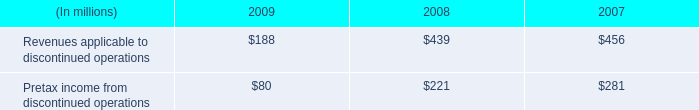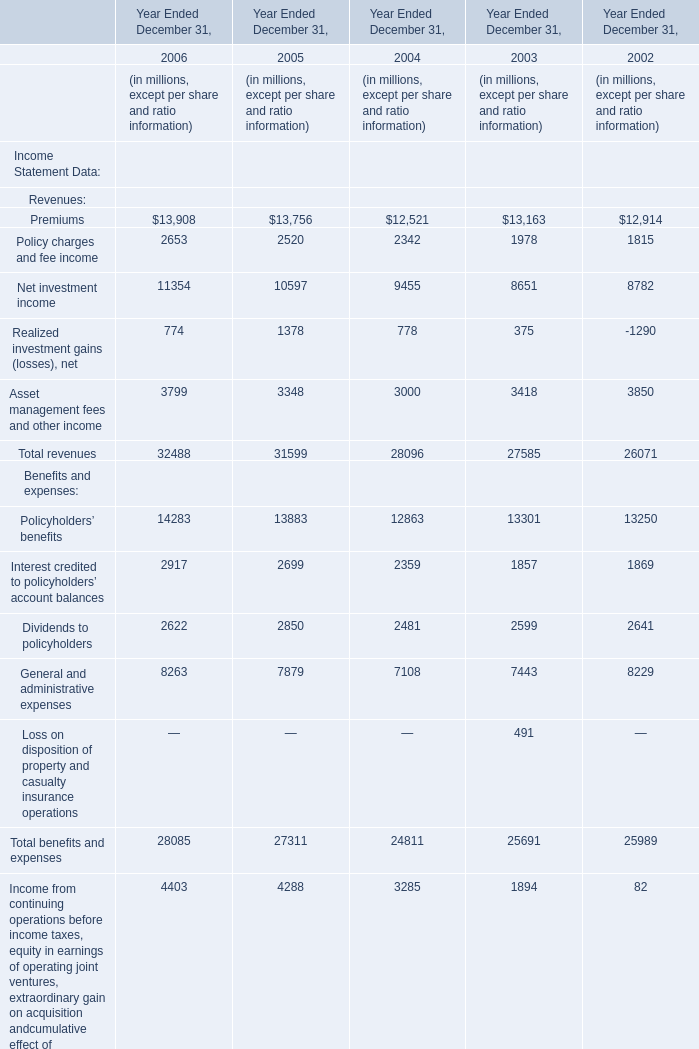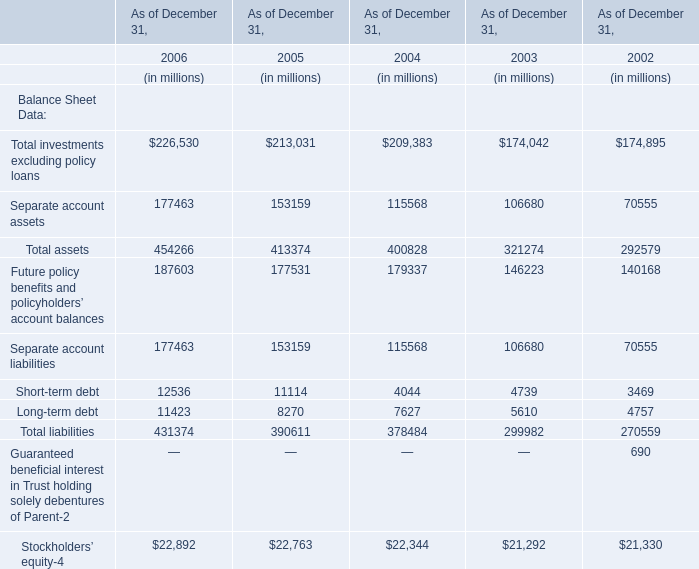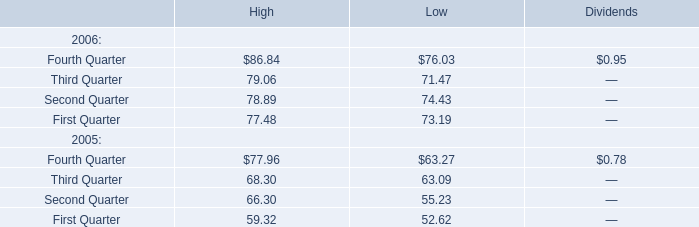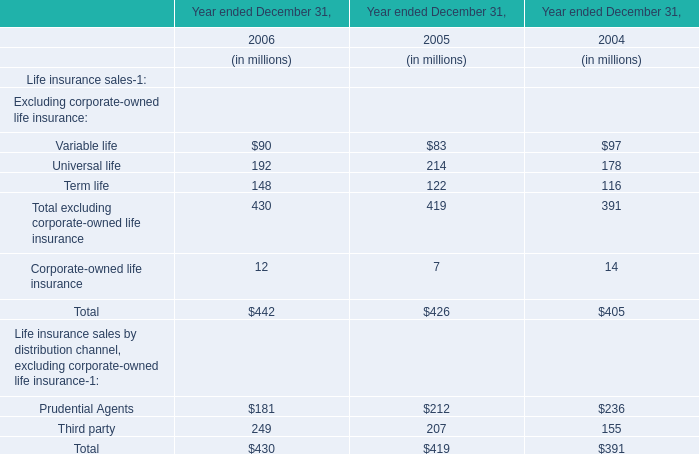What's the total amount of the Separate account assets in the years where Total investments excluding policy loans is greater than 200000? (in million) 
Computations: ((177463 + 153159) + 115568)
Answer: 446190.0. 